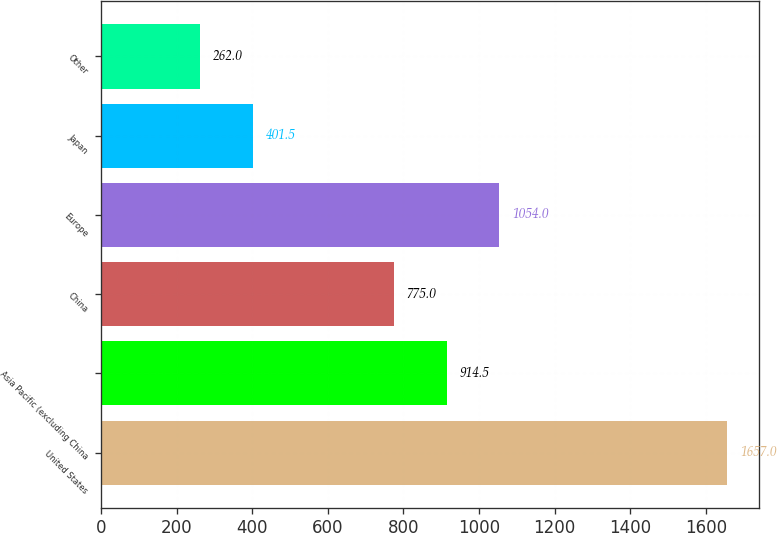Convert chart. <chart><loc_0><loc_0><loc_500><loc_500><bar_chart><fcel>United States<fcel>Asia Pacific (excluding China<fcel>China<fcel>Europe<fcel>Japan<fcel>Other<nl><fcel>1657<fcel>914.5<fcel>775<fcel>1054<fcel>401.5<fcel>262<nl></chart> 